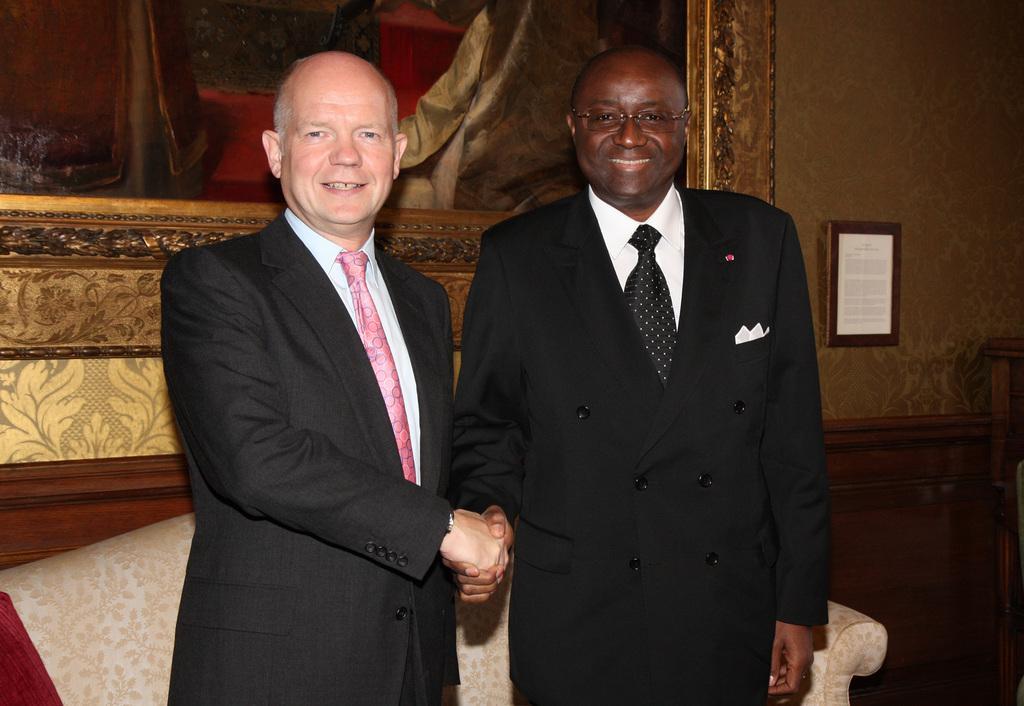In one or two sentences, can you explain what this image depicts? In this image I can see two people. I can see a sofa. In the background, I can see a photo frame on the wall. 